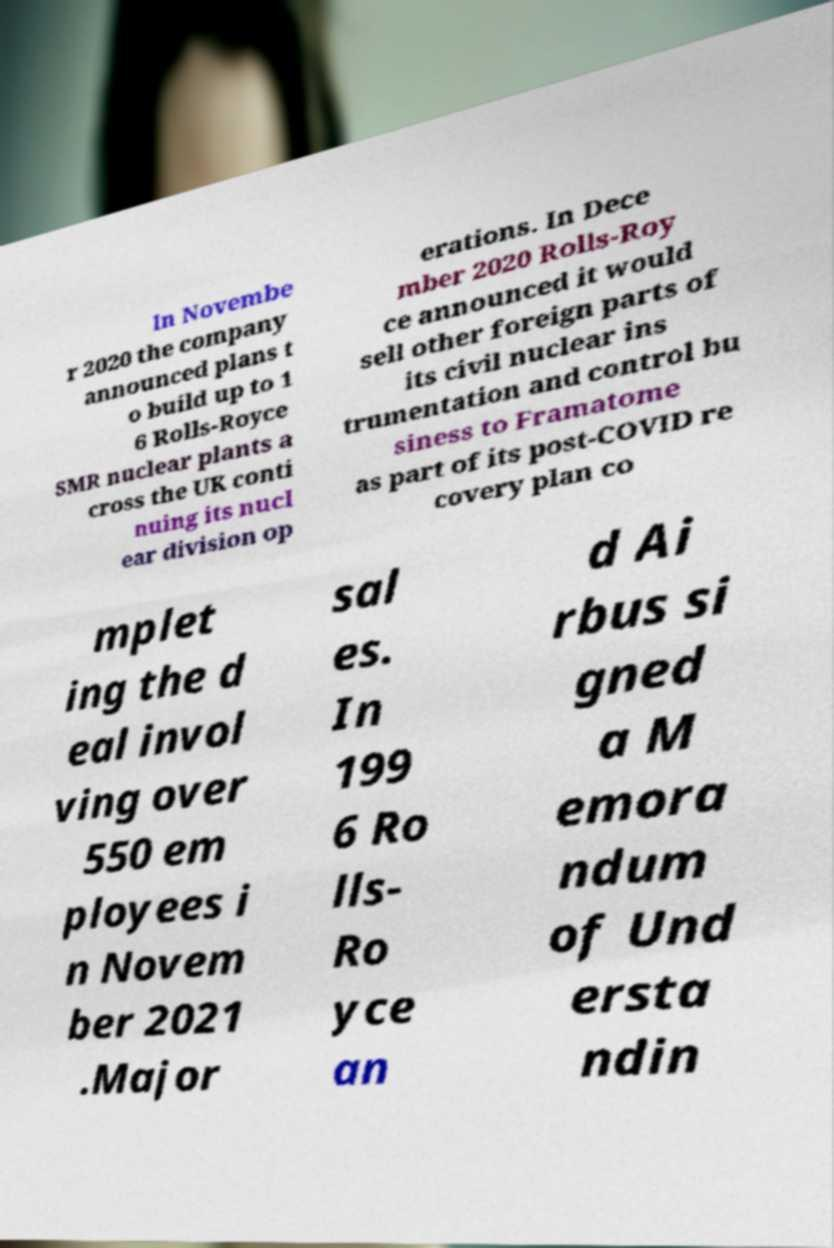Could you extract and type out the text from this image? In Novembe r 2020 the company announced plans t o build up to 1 6 Rolls-Royce SMR nuclear plants a cross the UK conti nuing its nucl ear division op erations. In Dece mber 2020 Rolls-Roy ce announced it would sell other foreign parts of its civil nuclear ins trumentation and control bu siness to Framatome as part of its post-COVID re covery plan co mplet ing the d eal invol ving over 550 em ployees i n Novem ber 2021 .Major sal es. In 199 6 Ro lls- Ro yce an d Ai rbus si gned a M emora ndum of Und ersta ndin 